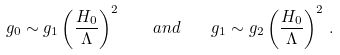<formula> <loc_0><loc_0><loc_500><loc_500>g _ { 0 } \sim g _ { 1 } \left ( \frac { H _ { 0 } } { \Lambda } \right ) ^ { 2 } \quad a n d \quad g _ { 1 } \sim g _ { 2 } \left ( \frac { H _ { 0 } } { \Lambda } \right ) ^ { 2 } \, .</formula> 